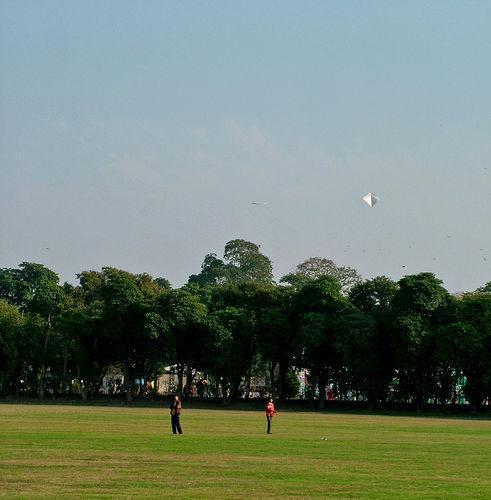How many people are standing in the field?
Give a very brief answer. 2. How many people are on the ground?
Give a very brief answer. 2. How many people are in the image?
Give a very brief answer. 2. 